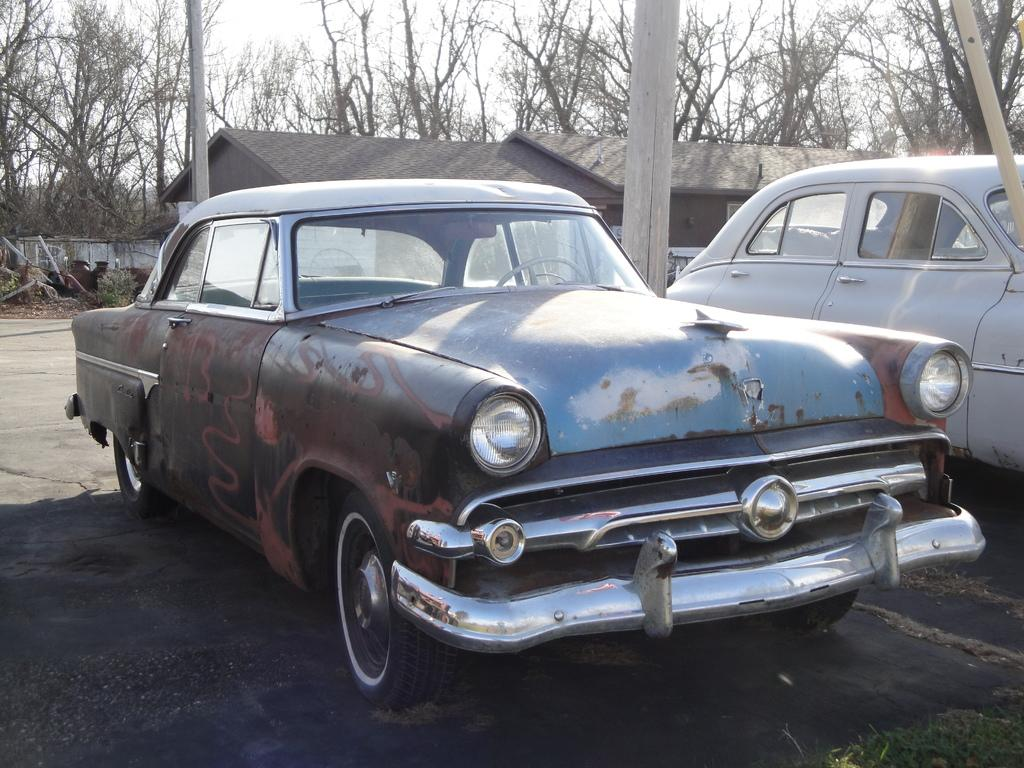What can be seen in the foreground of the image? There are two cars in the foreground of the image. What is the position of the cars in relation to the ground? The cars are on the ground. What can be seen in the background of the image? There are people, houses, trees, a wall, and the sky visible in the background of the image. Can you tell me how the dress is adjusting itself in the image? There is no dress present in the image, so it cannot be adjusted. How many birds can be seen flying in the image? There are no birds visible in the image, so they cannot be observed flying. 